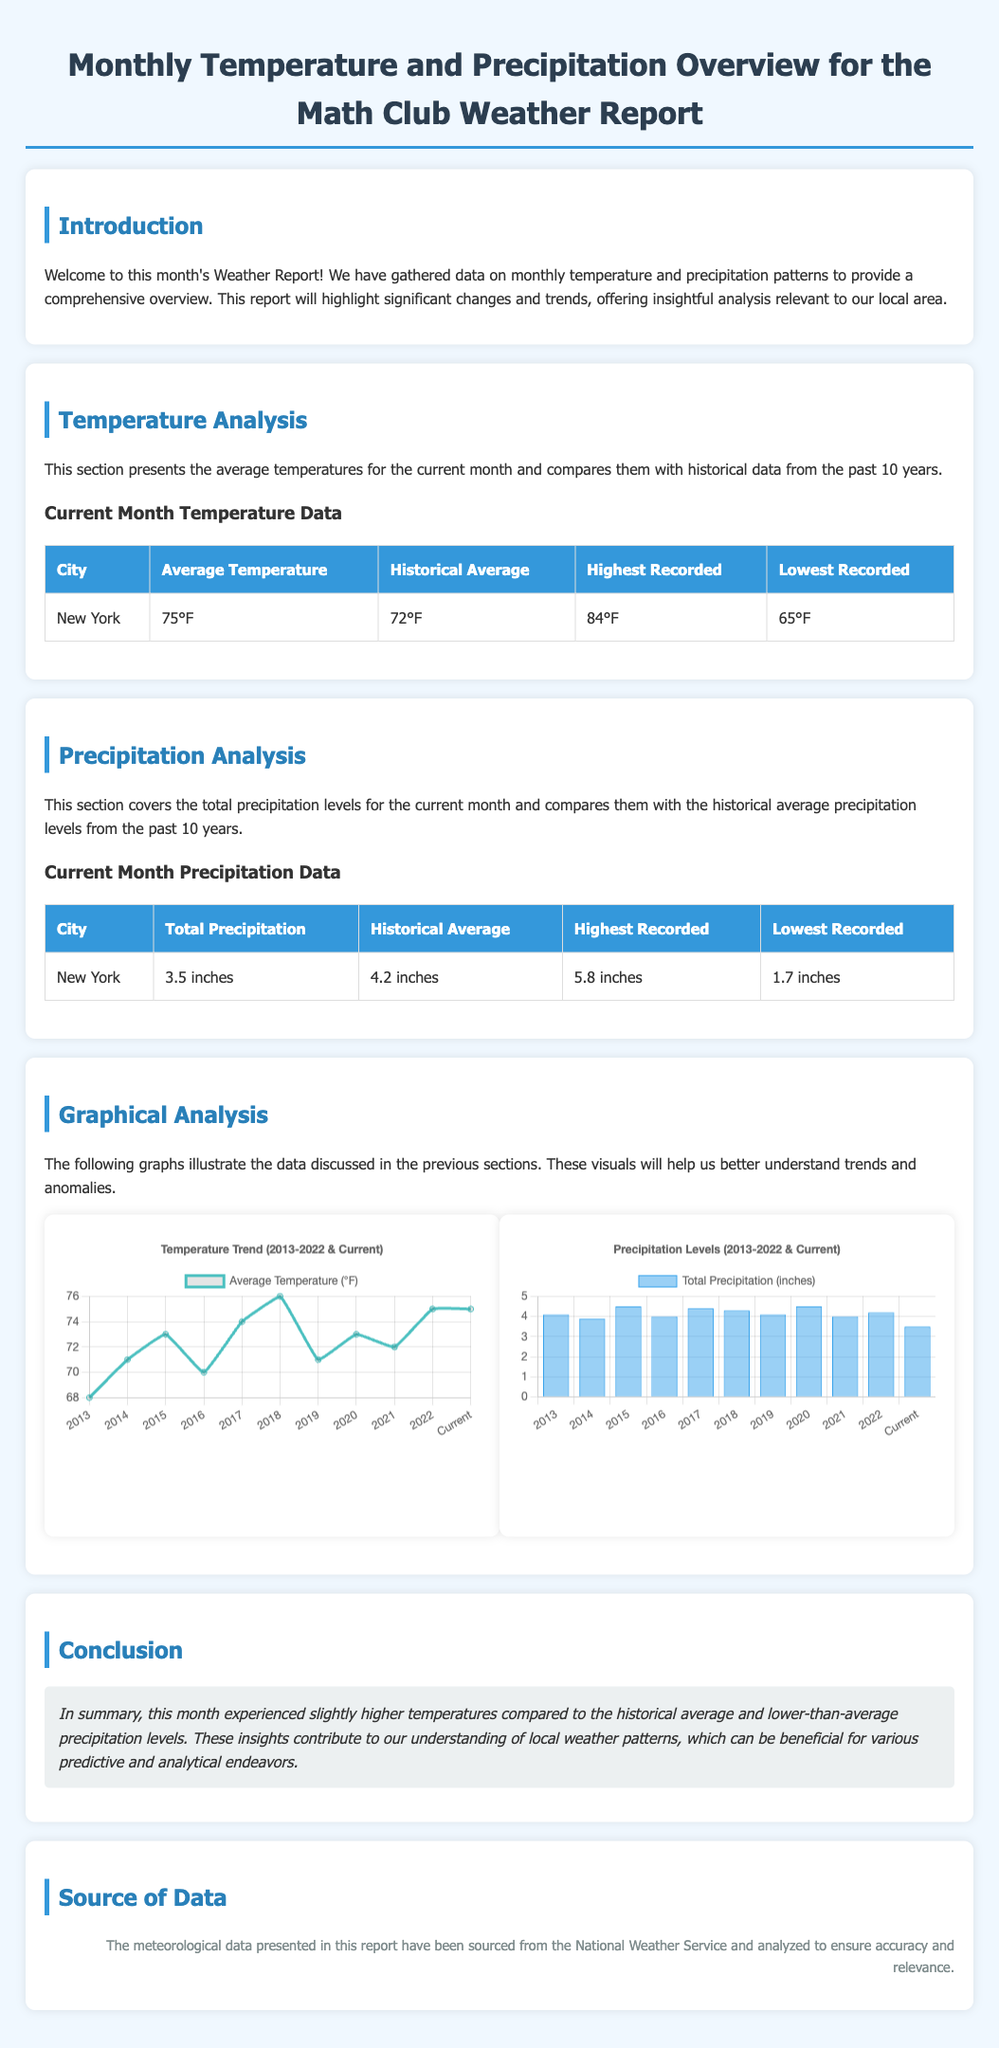What is the average temperature for New York this month? The average temperature for New York is listed in the table under "Current Month Temperature Data."
Answer: 75°F What was the highest recorded temperature in New York? The highest recorded temperature is mentioned in the same table under "Current Month Temperature Data."
Answer: 84°F What is the total precipitation for New York this month? The total precipitation is provided in the table under "Current Month Precipitation Data."
Answer: 3.5 inches How does the current month's total precipitation compare to the historical average? This required comparing the current month's total precipitation with the historical average listed in the table under "Current Month Precipitation Data."
Answer: Lower What temperature trend is shown in the temperature chart? This involves reasoning over the data presented in the "Temperature Trend" graph comparing historical years to the current one.
Answer: Increasing What year has the lowest average temperature recorded in the graph? This question asks for specific information from the graphical analysis of the temperature chart.
Answer: 2013 What is the historical average precipitation for New York? The historical average precipitation is mentioned in the table under "Current Month Precipitation Data."
Answer: 4.2 inches What color represents the average temperature in the temperature chart? This question pertains to the visual representation in the chart.
Answer: Cyan What is the title of the temperature chart? Based on the information displayed in the chart title within the document structure.
Answer: Temperature Trend (2013-2022 & Current) What serves as the source of data in this report? The source of information is mentioned at the end of the document.
Answer: National Weather Service 